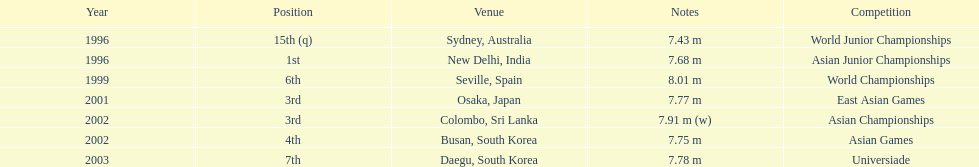What was the venue when he placed first? New Delhi, India. 